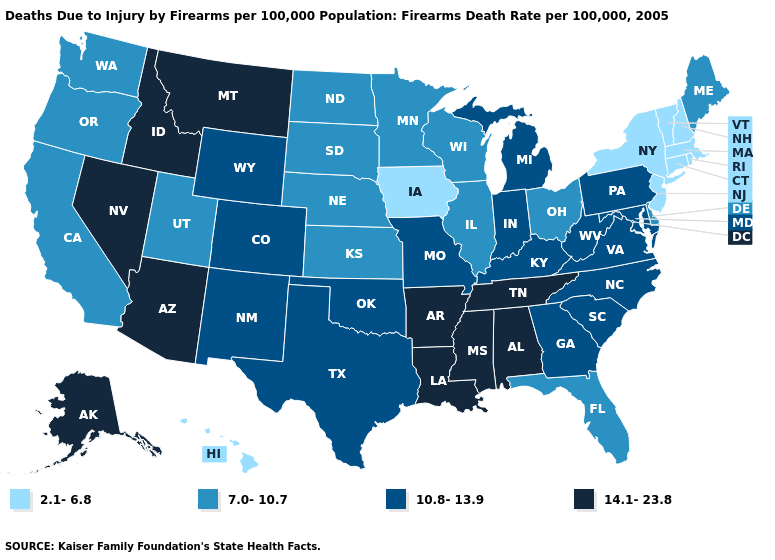Does Texas have a lower value than Alaska?
Answer briefly. Yes. Does the first symbol in the legend represent the smallest category?
Answer briefly. Yes. Name the states that have a value in the range 14.1-23.8?
Keep it brief. Alabama, Alaska, Arizona, Arkansas, Idaho, Louisiana, Mississippi, Montana, Nevada, Tennessee. Does Kansas have the lowest value in the MidWest?
Answer briefly. No. Among the states that border Minnesota , does North Dakota have the highest value?
Keep it brief. Yes. How many symbols are there in the legend?
Quick response, please. 4. Which states have the lowest value in the South?
Keep it brief. Delaware, Florida. What is the highest value in states that border Wisconsin?
Write a very short answer. 10.8-13.9. What is the value of Rhode Island?
Quick response, please. 2.1-6.8. Which states have the highest value in the USA?
Concise answer only. Alabama, Alaska, Arizona, Arkansas, Idaho, Louisiana, Mississippi, Montana, Nevada, Tennessee. Name the states that have a value in the range 10.8-13.9?
Quick response, please. Colorado, Georgia, Indiana, Kentucky, Maryland, Michigan, Missouri, New Mexico, North Carolina, Oklahoma, Pennsylvania, South Carolina, Texas, Virginia, West Virginia, Wyoming. What is the value of Montana?
Write a very short answer. 14.1-23.8. Name the states that have a value in the range 10.8-13.9?
Keep it brief. Colorado, Georgia, Indiana, Kentucky, Maryland, Michigan, Missouri, New Mexico, North Carolina, Oklahoma, Pennsylvania, South Carolina, Texas, Virginia, West Virginia, Wyoming. Name the states that have a value in the range 2.1-6.8?
Answer briefly. Connecticut, Hawaii, Iowa, Massachusetts, New Hampshire, New Jersey, New York, Rhode Island, Vermont. Which states have the lowest value in the South?
Keep it brief. Delaware, Florida. 